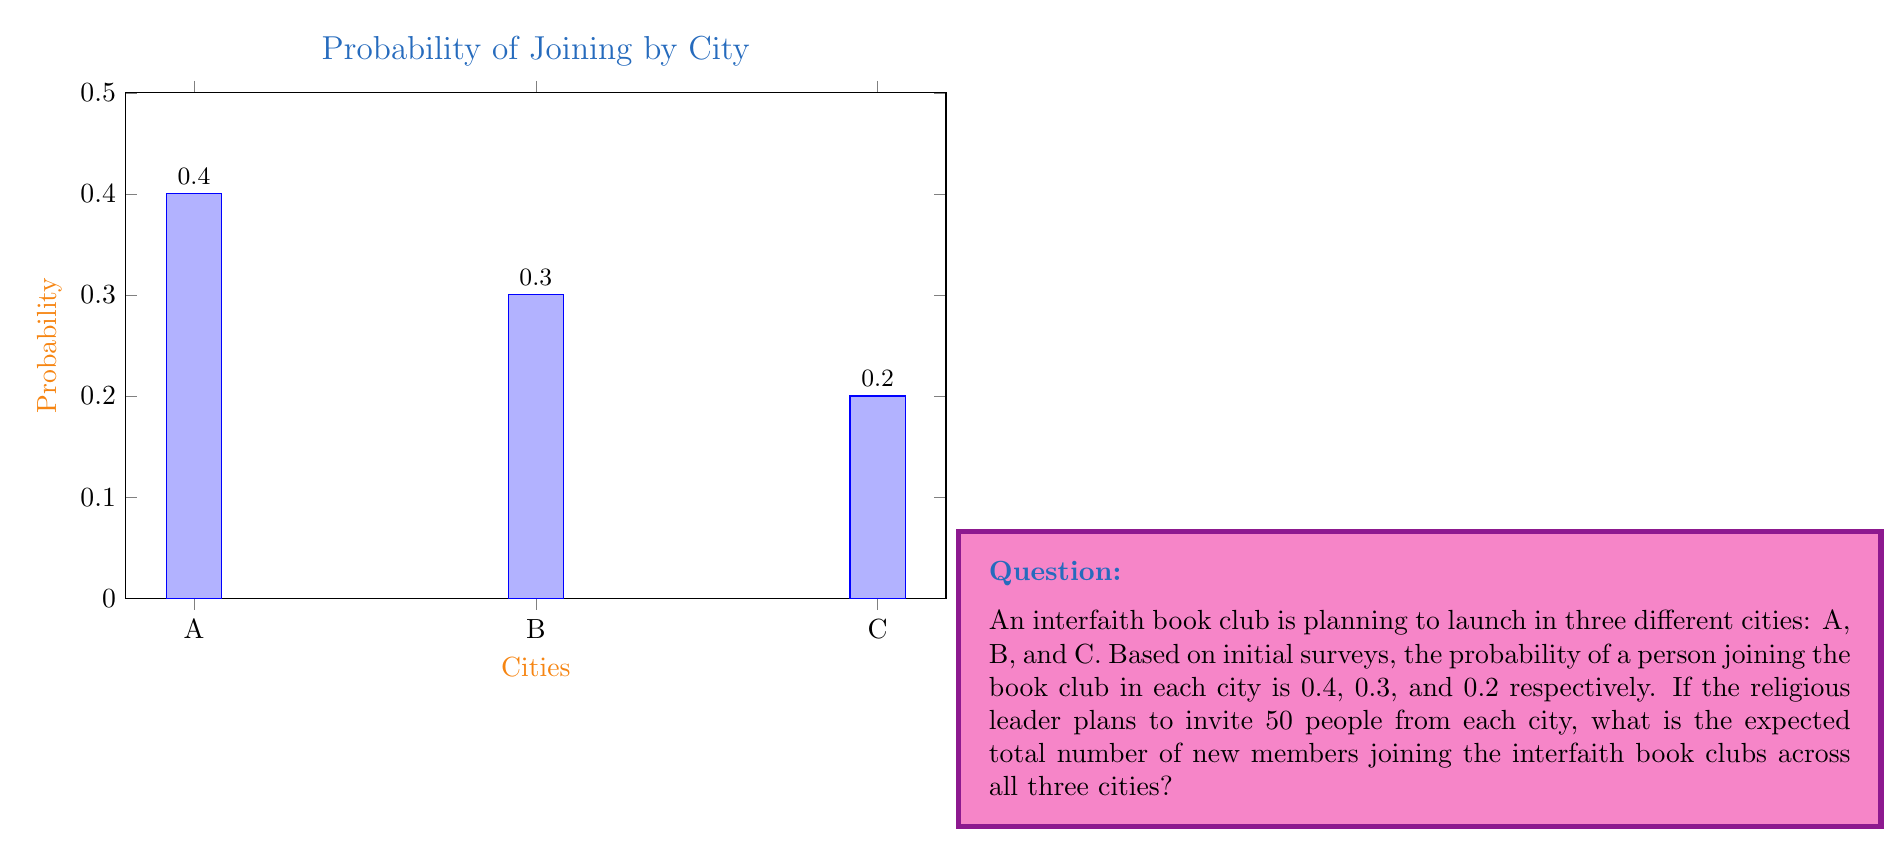Provide a solution to this math problem. To solve this problem, we'll use the concept of expected value. The expected value is calculated by multiplying the probability of an event by the number of times the event could occur.

Let's break it down step-by-step:

1) For each city, we need to calculate the expected number of new members:

   City A: $E(A) = 50 \times 0.4 = 20$
   City B: $E(B) = 50 \times 0.3 = 15$
   City C: $E(C) = 50 \times 0.2 = 10$

2) The total expected number of new members is the sum of the expected values from each city:

   $E(\text{Total}) = E(A) + E(B) + E(C)$

3) Substituting the values:

   $E(\text{Total}) = 20 + 15 + 10 = 45$

Therefore, the expected total number of new members joining the interfaith book clubs across all three cities is 45.
Answer: 45 members 